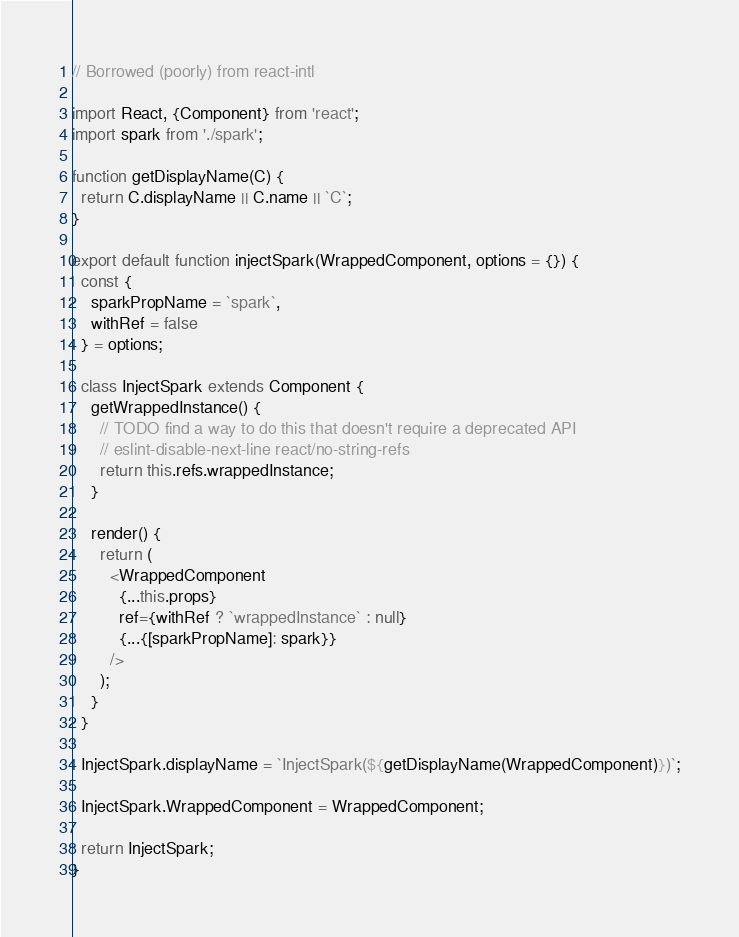<code> <loc_0><loc_0><loc_500><loc_500><_JavaScript_>// Borrowed (poorly) from react-intl

import React, {Component} from 'react';
import spark from './spark';

function getDisplayName(C) {
  return C.displayName || C.name || `C`;
}

export default function injectSpark(WrappedComponent, options = {}) {
  const {
    sparkPropName = `spark`,
    withRef = false
  } = options;

  class InjectSpark extends Component {
    getWrappedInstance() {
      // TODO find a way to do this that doesn't require a deprecated API
      // eslint-disable-next-line react/no-string-refs
      return this.refs.wrappedInstance;
    }

    render() {
      return (
        <WrappedComponent
          {...this.props}
          ref={withRef ? `wrappedInstance` : null}
          {...{[sparkPropName]: spark}}
        />
      );
    }
  }

  InjectSpark.displayName = `InjectSpark(${getDisplayName(WrappedComponent)})`;

  InjectSpark.WrappedComponent = WrappedComponent;

  return InjectSpark;
}
</code> 